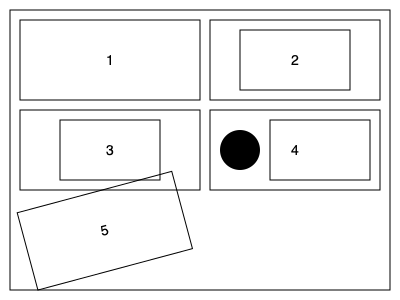As an indie filmmaker, which of the simplified scene diagrams above represents the "Over-the-Shoulder" shot composition? To identify the "Over-the-Shoulder" shot composition, let's analyze each diagram:

1. Diagram 1 shows a single, wide rectangle, typically representing a wide shot that captures the entire scene.

2. Diagram 2 displays a large rectangle with a smaller rectangle inside, usually indicating a medium shot focusing on a subject within the frame.

3. Diagram 3 presents a large rectangle with a smaller rectangle centered inside, often used to depict a close-up shot.

4. Diagram 4 shows a large rectangle with a small circle in the left corner and a smaller rectangle on the right side. This composition is characteristic of an over-the-shoulder shot, where the circle represents the back of a character's head or shoulder in the foreground, and the rectangle represents the subject being viewed.

5. Diagram 5 depicts a tilted rectangle, commonly used to represent a Dutch angle shot, where the camera is intentionally tilted to create a sense of unease or dynamic composition.

Based on this analysis, the diagram that represents the "Over-the-Shoulder" shot composition is number 4.
Answer: 4 